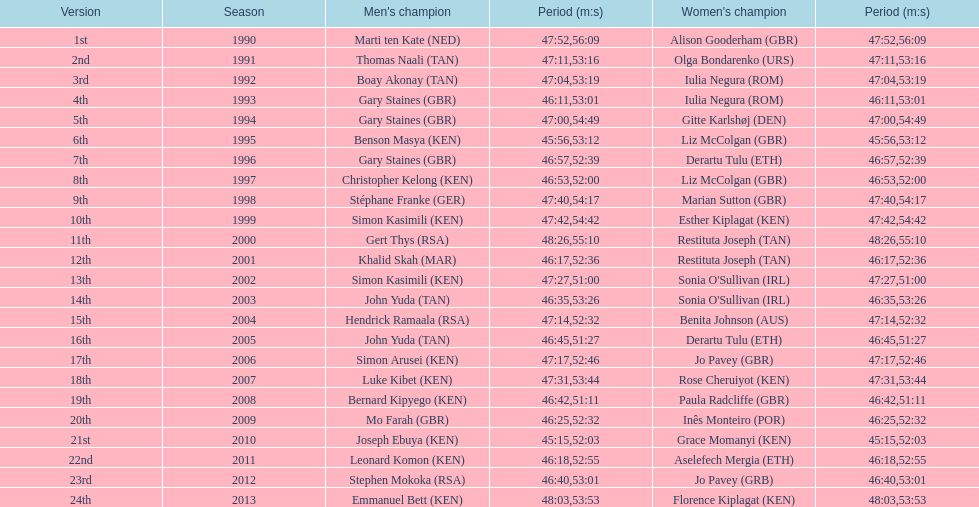Were there any instances where a woman was faster than a man? No. 